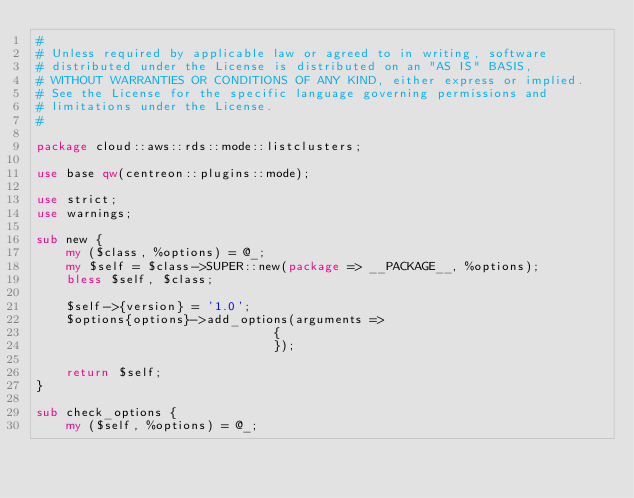<code> <loc_0><loc_0><loc_500><loc_500><_Perl_>#
# Unless required by applicable law or agreed to in writing, software
# distributed under the License is distributed on an "AS IS" BASIS,
# WITHOUT WARRANTIES OR CONDITIONS OF ANY KIND, either express or implied.
# See the License for the specific language governing permissions and
# limitations under the License.
#

package cloud::aws::rds::mode::listclusters;

use base qw(centreon::plugins::mode);

use strict;
use warnings;

sub new {
    my ($class, %options) = @_;
    my $self = $class->SUPER::new(package => __PACKAGE__, %options);
    bless $self, $class;
    
    $self->{version} = '1.0';
    $options{options}->add_options(arguments =>
                                {
                                });

    return $self;
}

sub check_options {
    my ($self, %options) = @_;</code> 